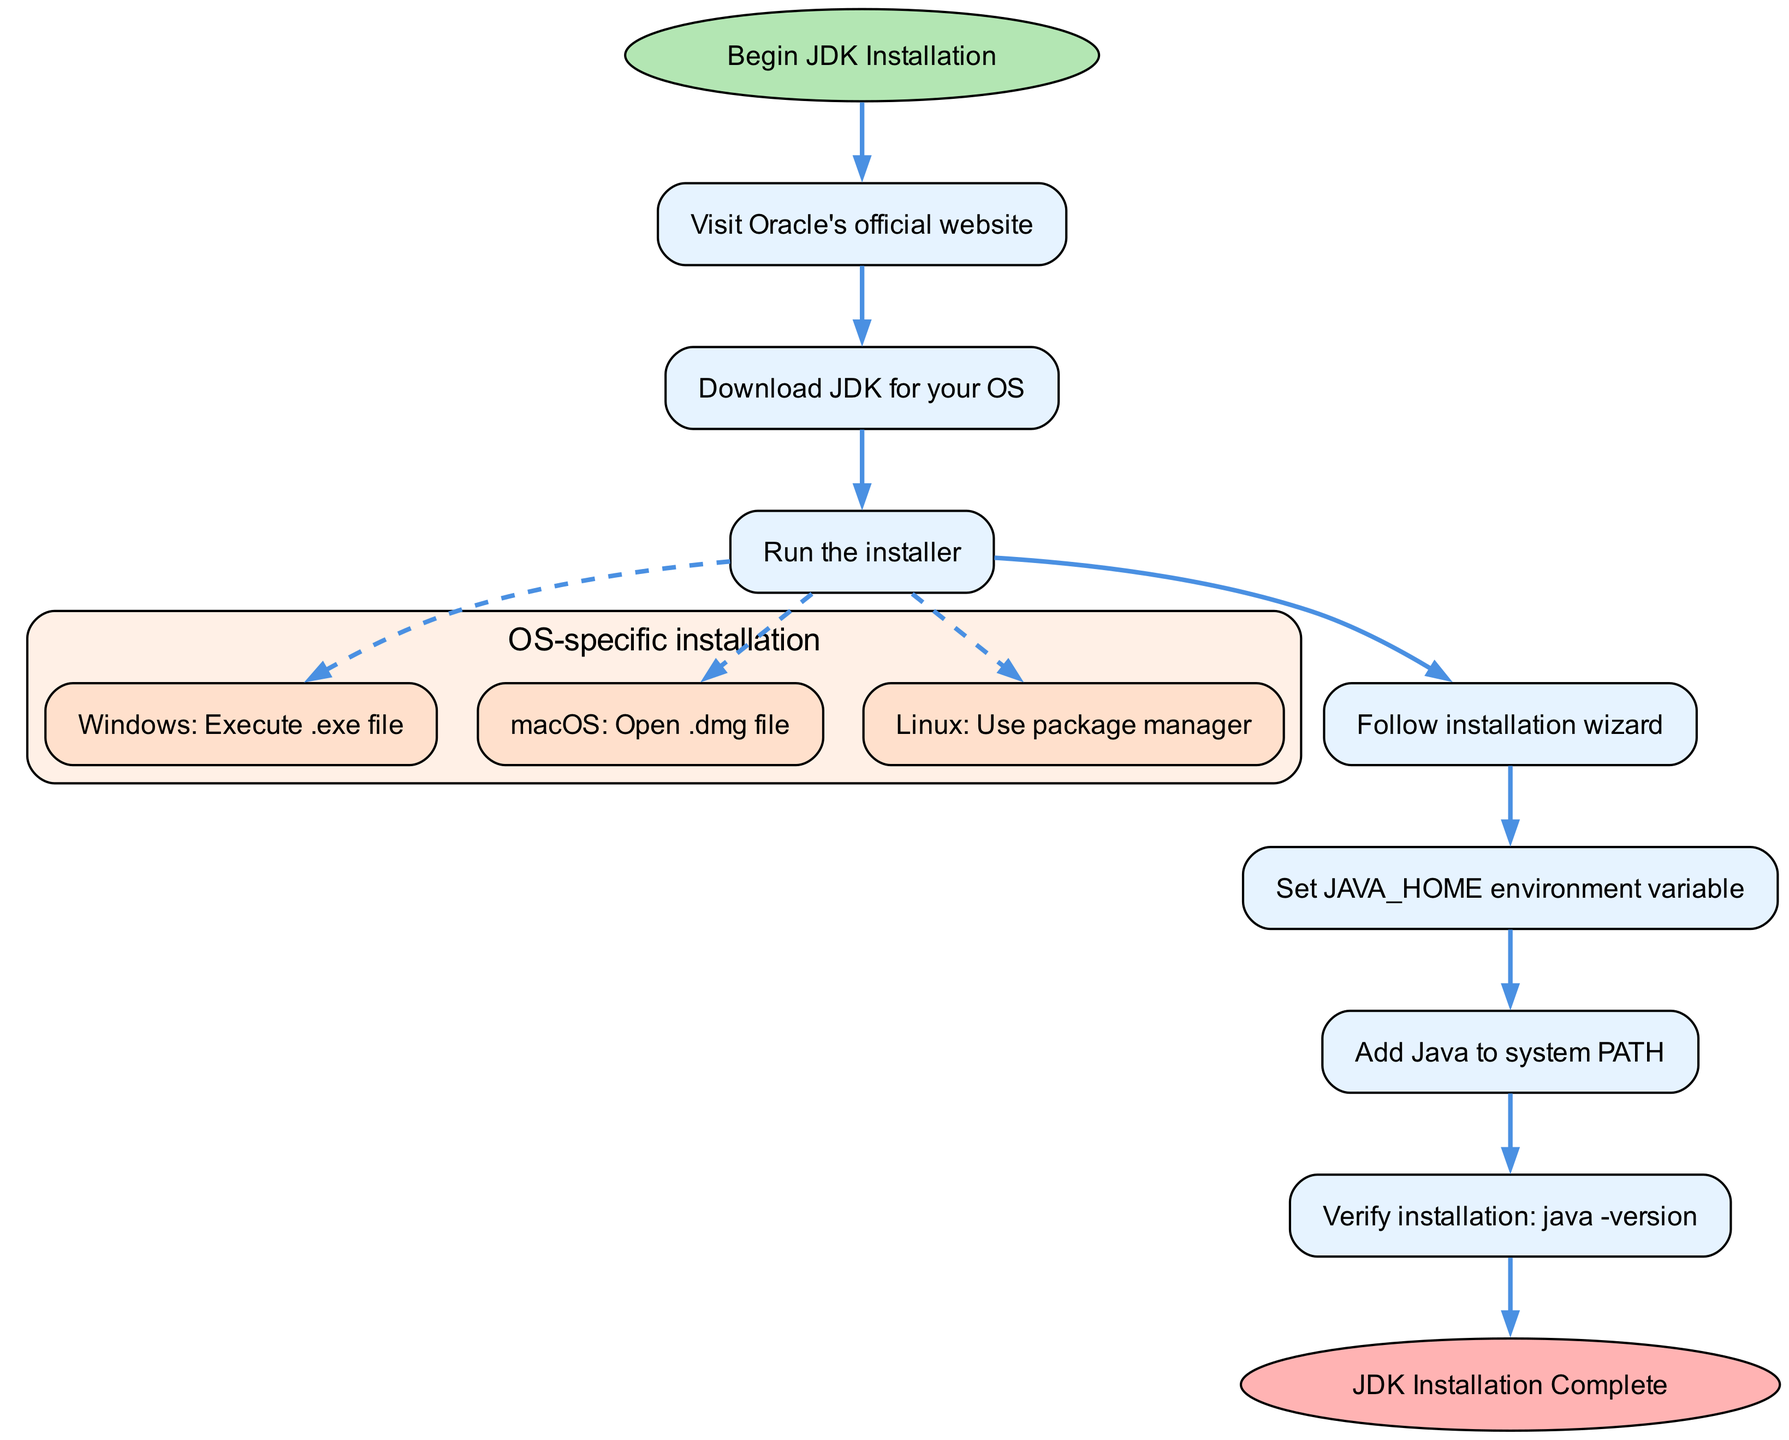What is the first step in the JDK installation process? The first step shown in the diagram is "Visit Oracle's official website," which is clearly labeled as step 1.
Answer: Visit Oracle's official website How many sub-steps are there in the installation process for Step 3? Step 3 contains three sub-steps, specified as "Windows: Execute .exe file," "macOS: Open .dmg file," and "Linux: Use package manager."
Answer: 3 Which operating system uses a .exe file during installation? The diagram indicates that Windows uses a .exe file, specifically mentioned in sub-step "3a" under Step 3.
Answer: Windows What do you need to do after running the installer? The diagram illustrates that after running the installer, you should "Follow installation wizard," which is Step 4.
Answer: Follow installation wizard What is the last step of the JDK installation process? According to the diagram, the final step of the installation process is "JDK Installation Complete," which signifies the end of the flow chart.
Answer: JDK Installation Complete How do you verify the JDK installation? The flow chart specifies that you can verify the installation by using the command "java -version," indicated as Step 7 in the process.
Answer: java -version What environment variable must be set during the installation? In the instructions, it is clearly stated in Step 5 that the JAVA_HOME environment variable must be set during the installation process.
Answer: JAVA_HOME What is the relationship between Step 1 and Step 2? The diagram shows a direct connection from Step 1 ("Visit Oracle's official website") to Step 2 ("Download JDK for your OS"), indicating that you must complete Step 1 before proceeding to Step 2.
Answer: Direct connection What color is the end node representing completion? The end node labeled “JDK Installation Complete” is shown in a light red shade as indicated by the fillcolor attribute in the diagram.
Answer: Light red 